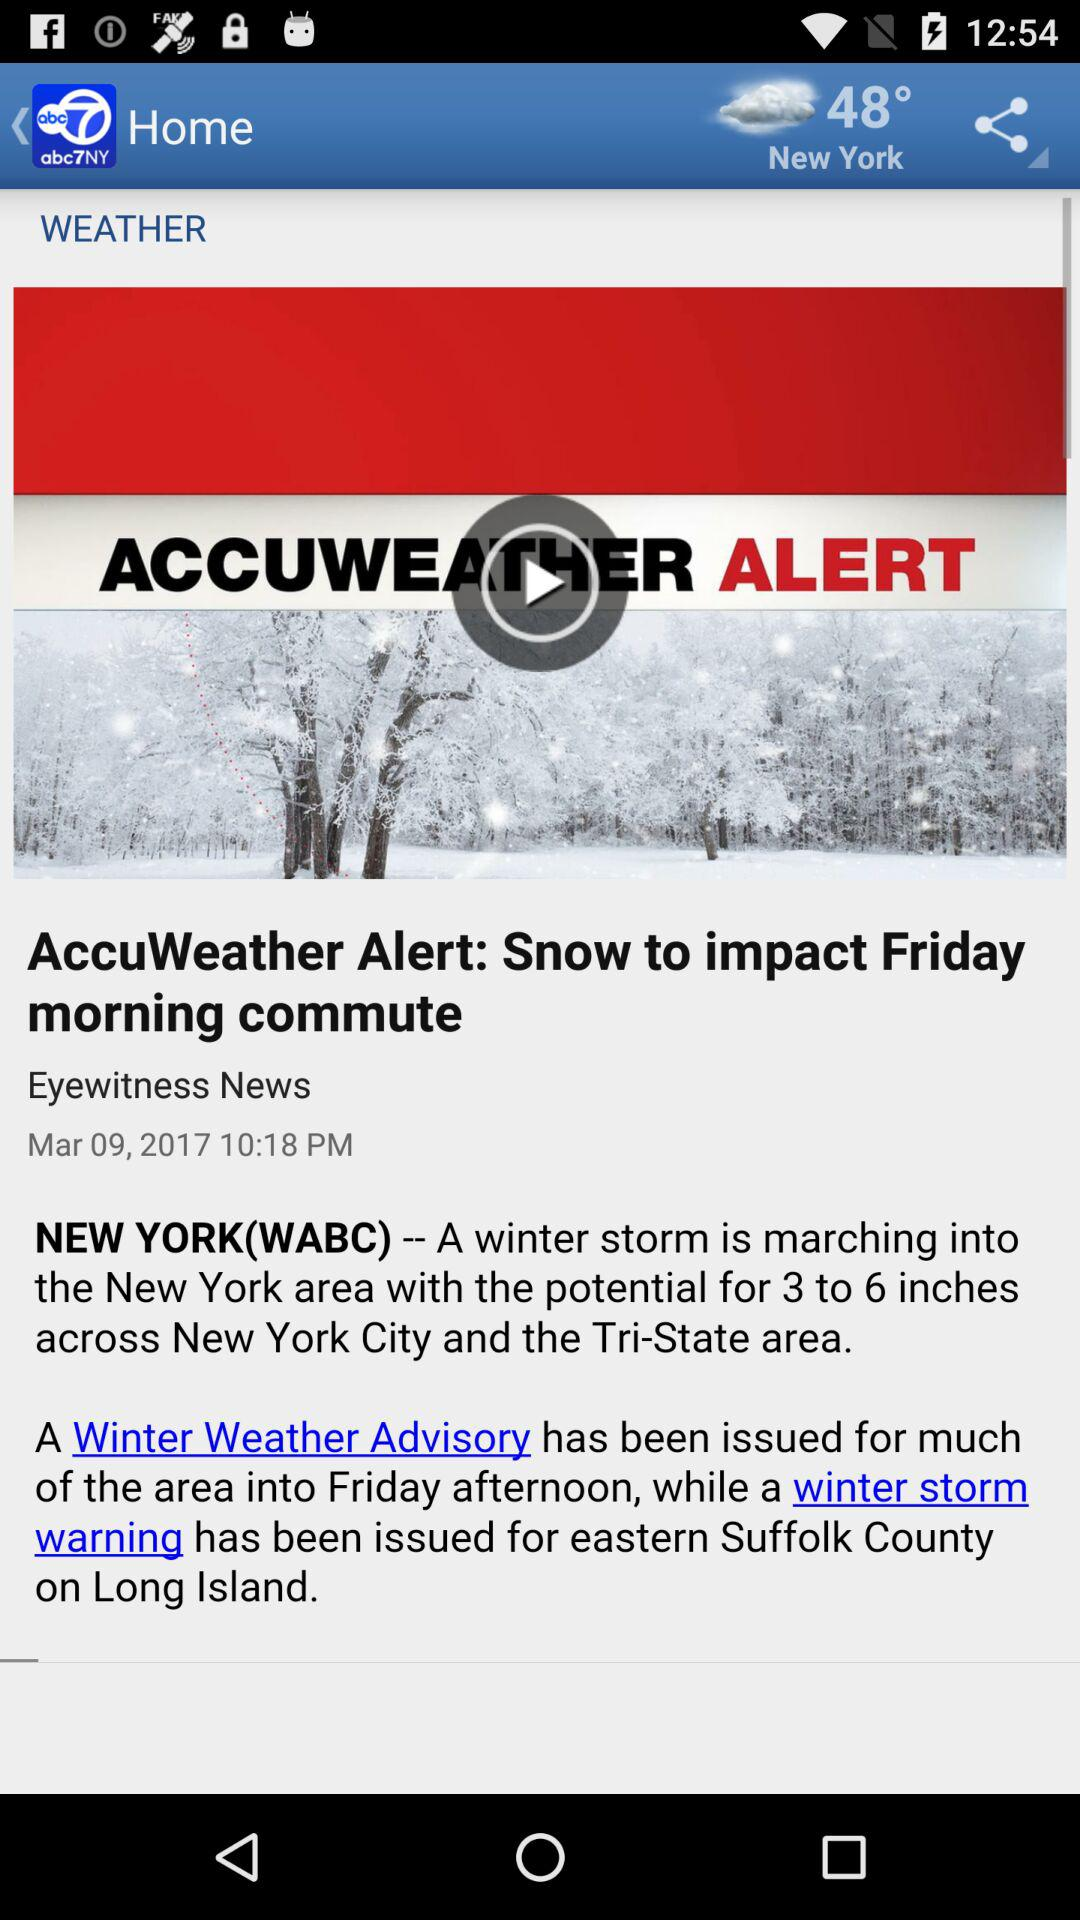What is the given temperature? The given temperature is 48°. 